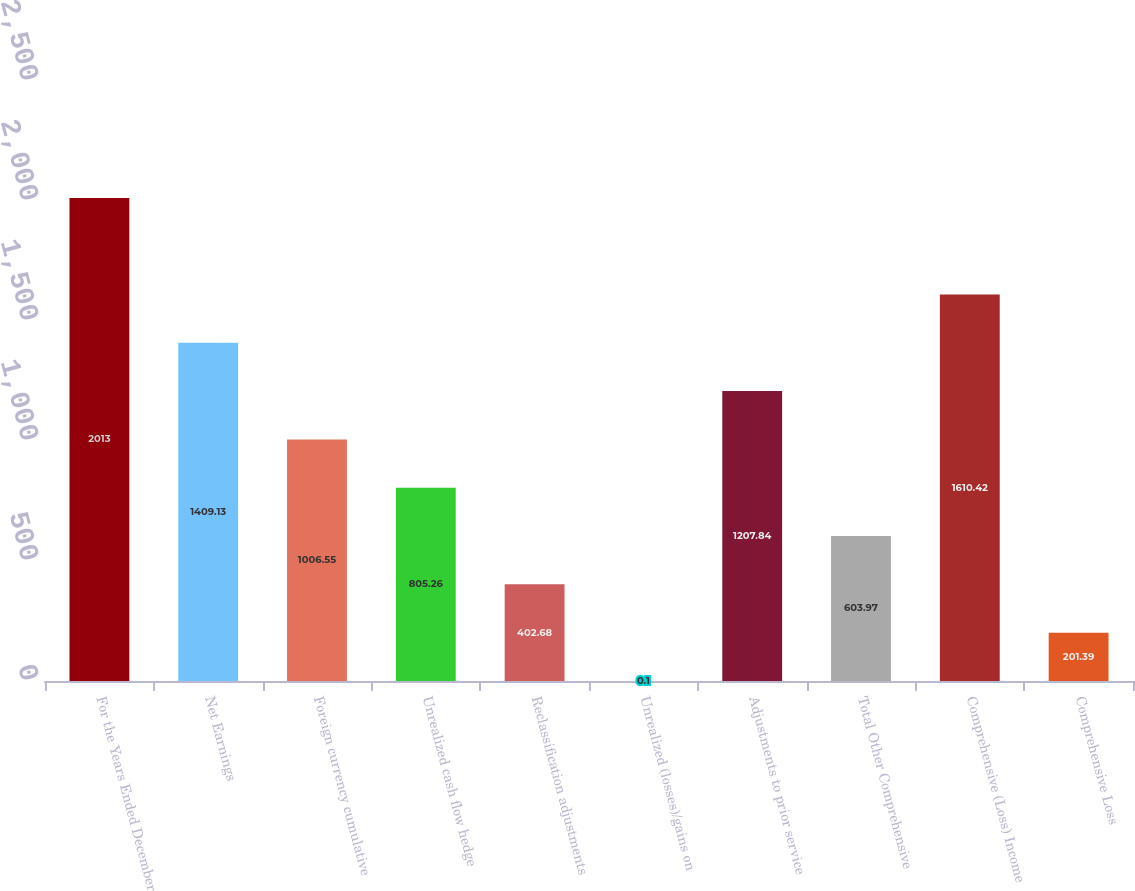Convert chart. <chart><loc_0><loc_0><loc_500><loc_500><bar_chart><fcel>For the Years Ended December<fcel>Net Earnings<fcel>Foreign currency cumulative<fcel>Unrealized cash flow hedge<fcel>Reclassification adjustments<fcel>Unrealized (losses)/gains on<fcel>Adjustments to prior service<fcel>Total Other Comprehensive<fcel>Comprehensive (Loss) Income<fcel>Comprehensive Loss<nl><fcel>2013<fcel>1409.13<fcel>1006.55<fcel>805.26<fcel>402.68<fcel>0.1<fcel>1207.84<fcel>603.97<fcel>1610.42<fcel>201.39<nl></chart> 